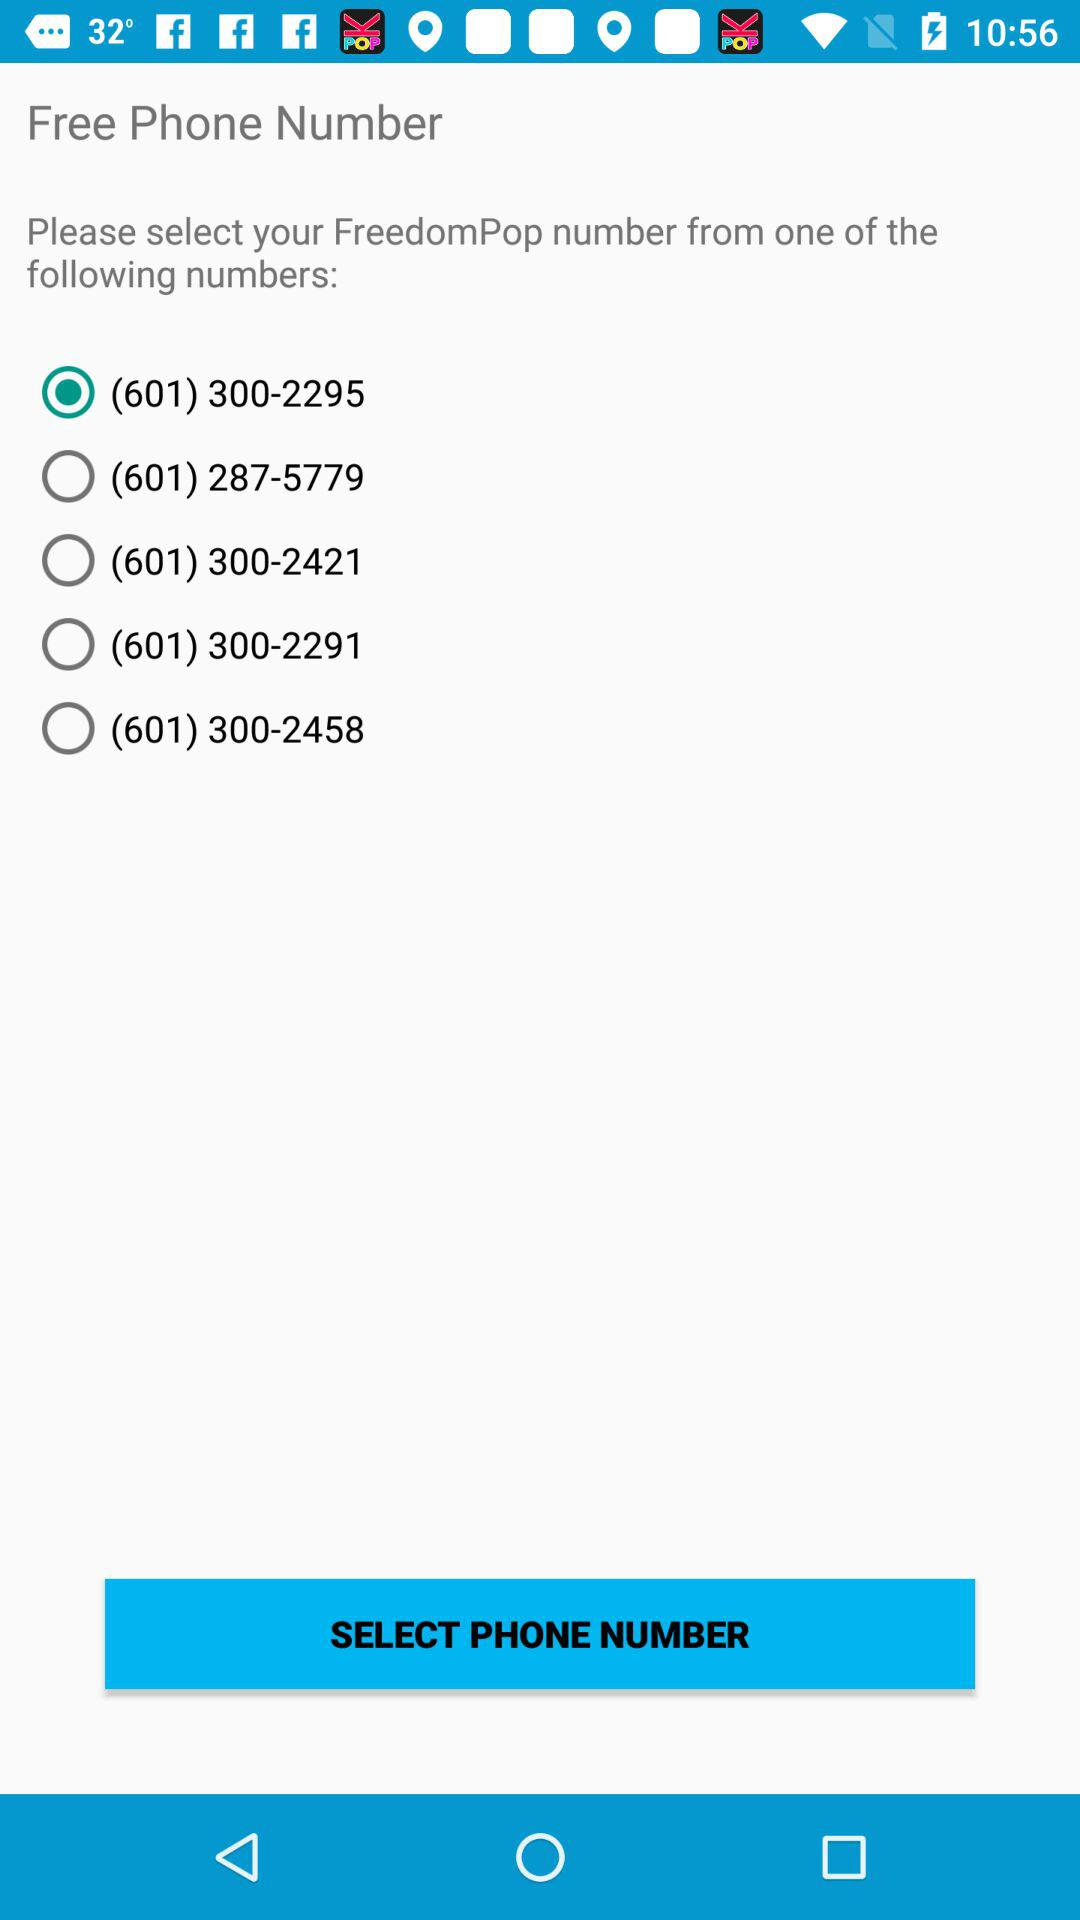Which phone number is selected? The selected phone number is (601) 300-2295. 